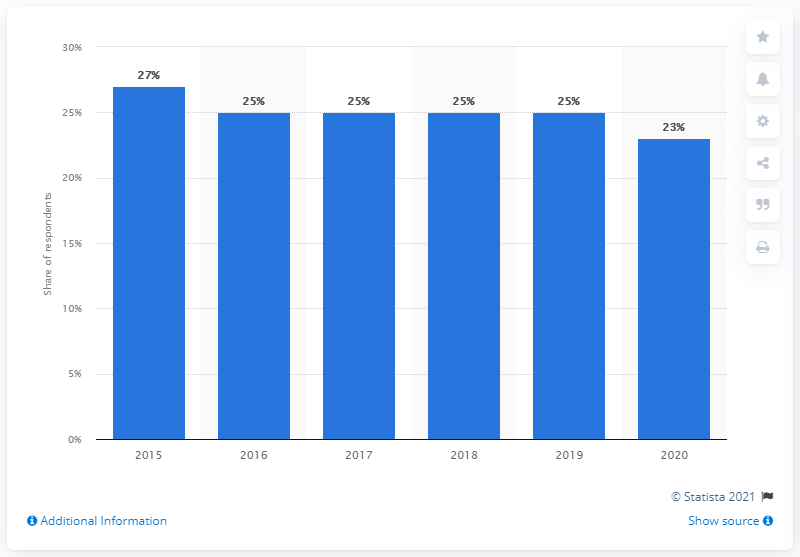Give some essential details in this illustration. In the UK in 2020, 23% of internet users had consumed content illegally online. 